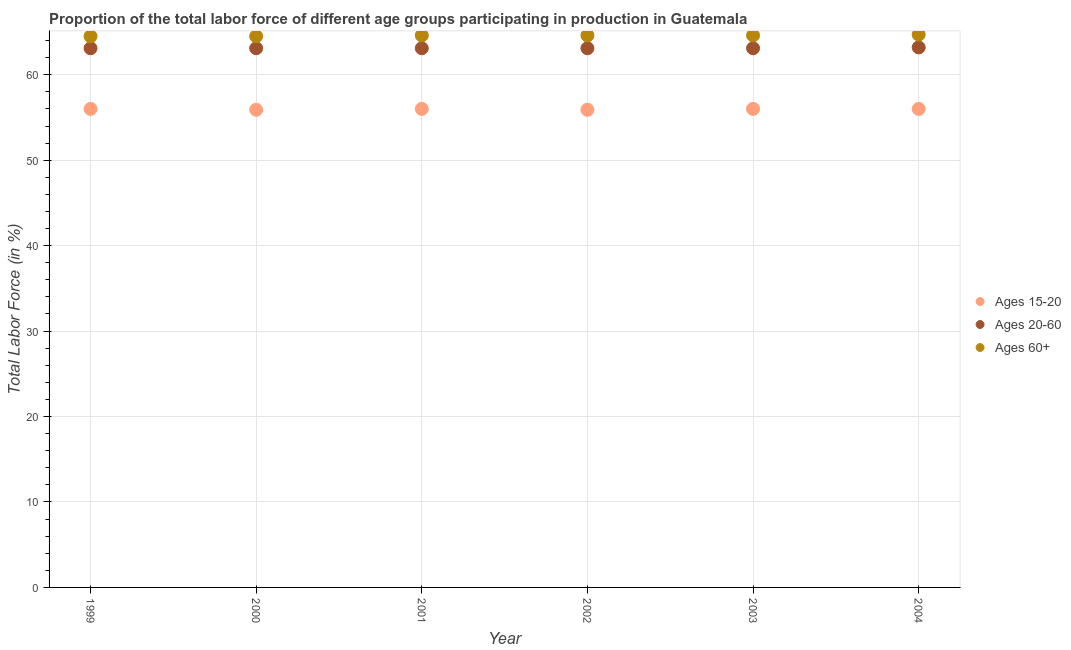How many different coloured dotlines are there?
Your answer should be compact. 3. Is the number of dotlines equal to the number of legend labels?
Give a very brief answer. Yes. Across all years, what is the maximum percentage of labor force within the age group 20-60?
Ensure brevity in your answer.  63.2. Across all years, what is the minimum percentage of labor force within the age group 15-20?
Keep it short and to the point. 55.9. In which year was the percentage of labor force above age 60 maximum?
Your answer should be compact. 2004. What is the total percentage of labor force within the age group 15-20 in the graph?
Your answer should be compact. 335.8. What is the difference between the percentage of labor force within the age group 20-60 in 2001 and the percentage of labor force within the age group 15-20 in 1999?
Provide a short and direct response. 7.1. What is the average percentage of labor force above age 60 per year?
Your answer should be very brief. 64.58. In the year 2001, what is the difference between the percentage of labor force above age 60 and percentage of labor force within the age group 20-60?
Your answer should be compact. 1.5. In how many years, is the percentage of labor force within the age group 20-60 greater than 32 %?
Your answer should be very brief. 6. What is the ratio of the percentage of labor force above age 60 in 2000 to that in 2004?
Offer a very short reply. 1. Is the percentage of labor force above age 60 in 2000 less than that in 2004?
Provide a succinct answer. Yes. Is the difference between the percentage of labor force within the age group 20-60 in 2002 and 2003 greater than the difference between the percentage of labor force above age 60 in 2002 and 2003?
Provide a short and direct response. No. What is the difference between the highest and the second highest percentage of labor force above age 60?
Keep it short and to the point. 0.1. What is the difference between the highest and the lowest percentage of labor force within the age group 15-20?
Give a very brief answer. 0.1. In how many years, is the percentage of labor force above age 60 greater than the average percentage of labor force above age 60 taken over all years?
Provide a short and direct response. 4. Is the sum of the percentage of labor force within the age group 20-60 in 2001 and 2002 greater than the maximum percentage of labor force above age 60 across all years?
Provide a succinct answer. Yes. Is it the case that in every year, the sum of the percentage of labor force within the age group 15-20 and percentage of labor force within the age group 20-60 is greater than the percentage of labor force above age 60?
Your answer should be very brief. Yes. Does the percentage of labor force within the age group 20-60 monotonically increase over the years?
Keep it short and to the point. No. What is the title of the graph?
Offer a terse response. Proportion of the total labor force of different age groups participating in production in Guatemala. What is the label or title of the X-axis?
Your answer should be compact. Year. What is the label or title of the Y-axis?
Keep it short and to the point. Total Labor Force (in %). What is the Total Labor Force (in %) of Ages 15-20 in 1999?
Your answer should be very brief. 56. What is the Total Labor Force (in %) of Ages 20-60 in 1999?
Your answer should be compact. 63.1. What is the Total Labor Force (in %) of Ages 60+ in 1999?
Ensure brevity in your answer.  64.5. What is the Total Labor Force (in %) of Ages 15-20 in 2000?
Offer a very short reply. 55.9. What is the Total Labor Force (in %) in Ages 20-60 in 2000?
Offer a very short reply. 63.1. What is the Total Labor Force (in %) in Ages 60+ in 2000?
Keep it short and to the point. 64.5. What is the Total Labor Force (in %) in Ages 15-20 in 2001?
Keep it short and to the point. 56. What is the Total Labor Force (in %) of Ages 20-60 in 2001?
Give a very brief answer. 63.1. What is the Total Labor Force (in %) of Ages 60+ in 2001?
Your answer should be compact. 64.6. What is the Total Labor Force (in %) of Ages 15-20 in 2002?
Provide a short and direct response. 55.9. What is the Total Labor Force (in %) in Ages 20-60 in 2002?
Offer a terse response. 63.1. What is the Total Labor Force (in %) in Ages 60+ in 2002?
Your answer should be very brief. 64.6. What is the Total Labor Force (in %) in Ages 15-20 in 2003?
Give a very brief answer. 56. What is the Total Labor Force (in %) of Ages 20-60 in 2003?
Your response must be concise. 63.1. What is the Total Labor Force (in %) in Ages 60+ in 2003?
Make the answer very short. 64.6. What is the Total Labor Force (in %) of Ages 15-20 in 2004?
Give a very brief answer. 56. What is the Total Labor Force (in %) in Ages 20-60 in 2004?
Keep it short and to the point. 63.2. What is the Total Labor Force (in %) in Ages 60+ in 2004?
Provide a short and direct response. 64.7. Across all years, what is the maximum Total Labor Force (in %) of Ages 20-60?
Make the answer very short. 63.2. Across all years, what is the maximum Total Labor Force (in %) of Ages 60+?
Ensure brevity in your answer.  64.7. Across all years, what is the minimum Total Labor Force (in %) in Ages 15-20?
Make the answer very short. 55.9. Across all years, what is the minimum Total Labor Force (in %) in Ages 20-60?
Give a very brief answer. 63.1. Across all years, what is the minimum Total Labor Force (in %) in Ages 60+?
Your answer should be compact. 64.5. What is the total Total Labor Force (in %) in Ages 15-20 in the graph?
Provide a short and direct response. 335.8. What is the total Total Labor Force (in %) in Ages 20-60 in the graph?
Offer a terse response. 378.7. What is the total Total Labor Force (in %) of Ages 60+ in the graph?
Your response must be concise. 387.5. What is the difference between the Total Labor Force (in %) of Ages 15-20 in 1999 and that in 2000?
Provide a short and direct response. 0.1. What is the difference between the Total Labor Force (in %) of Ages 20-60 in 1999 and that in 2001?
Offer a very short reply. 0. What is the difference between the Total Labor Force (in %) of Ages 15-20 in 1999 and that in 2002?
Keep it short and to the point. 0.1. What is the difference between the Total Labor Force (in %) of Ages 20-60 in 1999 and that in 2002?
Your answer should be very brief. 0. What is the difference between the Total Labor Force (in %) of Ages 60+ in 1999 and that in 2002?
Make the answer very short. -0.1. What is the difference between the Total Labor Force (in %) of Ages 60+ in 1999 and that in 2003?
Provide a succinct answer. -0.1. What is the difference between the Total Labor Force (in %) of Ages 15-20 in 2000 and that in 2002?
Your answer should be compact. 0. What is the difference between the Total Labor Force (in %) in Ages 20-60 in 2000 and that in 2002?
Your response must be concise. 0. What is the difference between the Total Labor Force (in %) in Ages 60+ in 2000 and that in 2003?
Offer a very short reply. -0.1. What is the difference between the Total Labor Force (in %) of Ages 15-20 in 2000 and that in 2004?
Your response must be concise. -0.1. What is the difference between the Total Labor Force (in %) in Ages 20-60 in 2000 and that in 2004?
Your answer should be very brief. -0.1. What is the difference between the Total Labor Force (in %) of Ages 15-20 in 2001 and that in 2002?
Ensure brevity in your answer.  0.1. What is the difference between the Total Labor Force (in %) of Ages 60+ in 2001 and that in 2004?
Provide a short and direct response. -0.1. What is the difference between the Total Labor Force (in %) in Ages 15-20 in 2002 and that in 2003?
Your answer should be compact. -0.1. What is the difference between the Total Labor Force (in %) of Ages 60+ in 2002 and that in 2003?
Make the answer very short. 0. What is the difference between the Total Labor Force (in %) of Ages 20-60 in 2002 and that in 2004?
Give a very brief answer. -0.1. What is the difference between the Total Labor Force (in %) in Ages 60+ in 2002 and that in 2004?
Keep it short and to the point. -0.1. What is the difference between the Total Labor Force (in %) in Ages 60+ in 2003 and that in 2004?
Keep it short and to the point. -0.1. What is the difference between the Total Labor Force (in %) in Ages 15-20 in 1999 and the Total Labor Force (in %) in Ages 20-60 in 2000?
Provide a succinct answer. -7.1. What is the difference between the Total Labor Force (in %) of Ages 15-20 in 1999 and the Total Labor Force (in %) of Ages 60+ in 2000?
Give a very brief answer. -8.5. What is the difference between the Total Labor Force (in %) of Ages 15-20 in 1999 and the Total Labor Force (in %) of Ages 60+ in 2001?
Your response must be concise. -8.6. What is the difference between the Total Labor Force (in %) of Ages 20-60 in 1999 and the Total Labor Force (in %) of Ages 60+ in 2001?
Provide a succinct answer. -1.5. What is the difference between the Total Labor Force (in %) in Ages 15-20 in 1999 and the Total Labor Force (in %) in Ages 20-60 in 2002?
Your answer should be very brief. -7.1. What is the difference between the Total Labor Force (in %) in Ages 15-20 in 1999 and the Total Labor Force (in %) in Ages 60+ in 2002?
Your response must be concise. -8.6. What is the difference between the Total Labor Force (in %) of Ages 15-20 in 1999 and the Total Labor Force (in %) of Ages 20-60 in 2003?
Your answer should be very brief. -7.1. What is the difference between the Total Labor Force (in %) in Ages 15-20 in 2000 and the Total Labor Force (in %) in Ages 20-60 in 2003?
Provide a short and direct response. -7.2. What is the difference between the Total Labor Force (in %) of Ages 15-20 in 2000 and the Total Labor Force (in %) of Ages 60+ in 2003?
Keep it short and to the point. -8.7. What is the difference between the Total Labor Force (in %) in Ages 20-60 in 2000 and the Total Labor Force (in %) in Ages 60+ in 2003?
Your response must be concise. -1.5. What is the difference between the Total Labor Force (in %) of Ages 20-60 in 2000 and the Total Labor Force (in %) of Ages 60+ in 2004?
Ensure brevity in your answer.  -1.6. What is the difference between the Total Labor Force (in %) of Ages 20-60 in 2001 and the Total Labor Force (in %) of Ages 60+ in 2002?
Your response must be concise. -1.5. What is the difference between the Total Labor Force (in %) in Ages 15-20 in 2001 and the Total Labor Force (in %) in Ages 20-60 in 2003?
Give a very brief answer. -7.1. What is the difference between the Total Labor Force (in %) in Ages 15-20 in 2001 and the Total Labor Force (in %) in Ages 20-60 in 2004?
Ensure brevity in your answer.  -7.2. What is the difference between the Total Labor Force (in %) of Ages 15-20 in 2002 and the Total Labor Force (in %) of Ages 20-60 in 2003?
Your response must be concise. -7.2. What is the difference between the Total Labor Force (in %) of Ages 20-60 in 2002 and the Total Labor Force (in %) of Ages 60+ in 2003?
Ensure brevity in your answer.  -1.5. What is the difference between the Total Labor Force (in %) in Ages 15-20 in 2002 and the Total Labor Force (in %) in Ages 20-60 in 2004?
Keep it short and to the point. -7.3. What is the difference between the Total Labor Force (in %) in Ages 15-20 in 2002 and the Total Labor Force (in %) in Ages 60+ in 2004?
Ensure brevity in your answer.  -8.8. What is the difference between the Total Labor Force (in %) in Ages 20-60 in 2002 and the Total Labor Force (in %) in Ages 60+ in 2004?
Your answer should be compact. -1.6. What is the difference between the Total Labor Force (in %) of Ages 15-20 in 2003 and the Total Labor Force (in %) of Ages 20-60 in 2004?
Your response must be concise. -7.2. What is the difference between the Total Labor Force (in %) in Ages 15-20 in 2003 and the Total Labor Force (in %) in Ages 60+ in 2004?
Keep it short and to the point. -8.7. What is the difference between the Total Labor Force (in %) in Ages 20-60 in 2003 and the Total Labor Force (in %) in Ages 60+ in 2004?
Ensure brevity in your answer.  -1.6. What is the average Total Labor Force (in %) of Ages 15-20 per year?
Make the answer very short. 55.97. What is the average Total Labor Force (in %) of Ages 20-60 per year?
Make the answer very short. 63.12. What is the average Total Labor Force (in %) of Ages 60+ per year?
Keep it short and to the point. 64.58. In the year 1999, what is the difference between the Total Labor Force (in %) of Ages 20-60 and Total Labor Force (in %) of Ages 60+?
Ensure brevity in your answer.  -1.4. In the year 2000, what is the difference between the Total Labor Force (in %) of Ages 15-20 and Total Labor Force (in %) of Ages 20-60?
Your response must be concise. -7.2. In the year 2000, what is the difference between the Total Labor Force (in %) in Ages 20-60 and Total Labor Force (in %) in Ages 60+?
Your answer should be compact. -1.4. In the year 2002, what is the difference between the Total Labor Force (in %) in Ages 15-20 and Total Labor Force (in %) in Ages 20-60?
Give a very brief answer. -7.2. In the year 2003, what is the difference between the Total Labor Force (in %) in Ages 20-60 and Total Labor Force (in %) in Ages 60+?
Offer a very short reply. -1.5. In the year 2004, what is the difference between the Total Labor Force (in %) in Ages 15-20 and Total Labor Force (in %) in Ages 20-60?
Provide a succinct answer. -7.2. In the year 2004, what is the difference between the Total Labor Force (in %) in Ages 15-20 and Total Labor Force (in %) in Ages 60+?
Make the answer very short. -8.7. In the year 2004, what is the difference between the Total Labor Force (in %) of Ages 20-60 and Total Labor Force (in %) of Ages 60+?
Offer a terse response. -1.5. What is the ratio of the Total Labor Force (in %) of Ages 15-20 in 1999 to that in 2000?
Ensure brevity in your answer.  1. What is the ratio of the Total Labor Force (in %) in Ages 20-60 in 1999 to that in 2000?
Your answer should be compact. 1. What is the ratio of the Total Labor Force (in %) in Ages 15-20 in 1999 to that in 2002?
Your response must be concise. 1. What is the ratio of the Total Labor Force (in %) of Ages 20-60 in 1999 to that in 2003?
Offer a very short reply. 1. What is the ratio of the Total Labor Force (in %) of Ages 15-20 in 2000 to that in 2001?
Your response must be concise. 1. What is the ratio of the Total Labor Force (in %) of Ages 20-60 in 2000 to that in 2001?
Your answer should be compact. 1. What is the ratio of the Total Labor Force (in %) in Ages 60+ in 2000 to that in 2001?
Keep it short and to the point. 1. What is the ratio of the Total Labor Force (in %) of Ages 15-20 in 2000 to that in 2002?
Keep it short and to the point. 1. What is the ratio of the Total Labor Force (in %) of Ages 20-60 in 2000 to that in 2002?
Offer a very short reply. 1. What is the ratio of the Total Labor Force (in %) of Ages 60+ in 2000 to that in 2002?
Offer a very short reply. 1. What is the ratio of the Total Labor Force (in %) of Ages 20-60 in 2000 to that in 2003?
Keep it short and to the point. 1. What is the ratio of the Total Labor Force (in %) in Ages 60+ in 2000 to that in 2003?
Keep it short and to the point. 1. What is the ratio of the Total Labor Force (in %) in Ages 15-20 in 2000 to that in 2004?
Offer a terse response. 1. What is the ratio of the Total Labor Force (in %) in Ages 20-60 in 2000 to that in 2004?
Ensure brevity in your answer.  1. What is the ratio of the Total Labor Force (in %) of Ages 60+ in 2000 to that in 2004?
Provide a short and direct response. 1. What is the ratio of the Total Labor Force (in %) of Ages 15-20 in 2001 to that in 2002?
Your answer should be compact. 1. What is the ratio of the Total Labor Force (in %) of Ages 60+ in 2001 to that in 2002?
Ensure brevity in your answer.  1. What is the ratio of the Total Labor Force (in %) in Ages 60+ in 2001 to that in 2003?
Offer a very short reply. 1. What is the ratio of the Total Labor Force (in %) in Ages 15-20 in 2001 to that in 2004?
Provide a succinct answer. 1. What is the ratio of the Total Labor Force (in %) of Ages 60+ in 2002 to that in 2003?
Provide a succinct answer. 1. What is the ratio of the Total Labor Force (in %) of Ages 15-20 in 2002 to that in 2004?
Make the answer very short. 1. What is the ratio of the Total Labor Force (in %) in Ages 20-60 in 2002 to that in 2004?
Offer a terse response. 1. What is the ratio of the Total Labor Force (in %) of Ages 15-20 in 2003 to that in 2004?
Give a very brief answer. 1. What is the ratio of the Total Labor Force (in %) of Ages 20-60 in 2003 to that in 2004?
Your answer should be very brief. 1. What is the difference between the highest and the second highest Total Labor Force (in %) in Ages 15-20?
Keep it short and to the point. 0. What is the difference between the highest and the lowest Total Labor Force (in %) of Ages 15-20?
Provide a short and direct response. 0.1. 